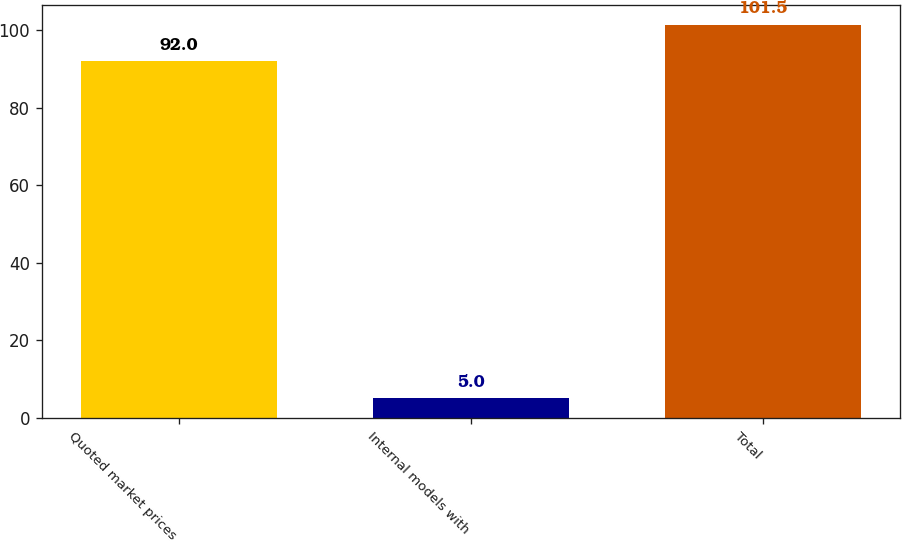<chart> <loc_0><loc_0><loc_500><loc_500><bar_chart><fcel>Quoted market prices<fcel>Internal models with<fcel>Total<nl><fcel>92<fcel>5<fcel>101.5<nl></chart> 